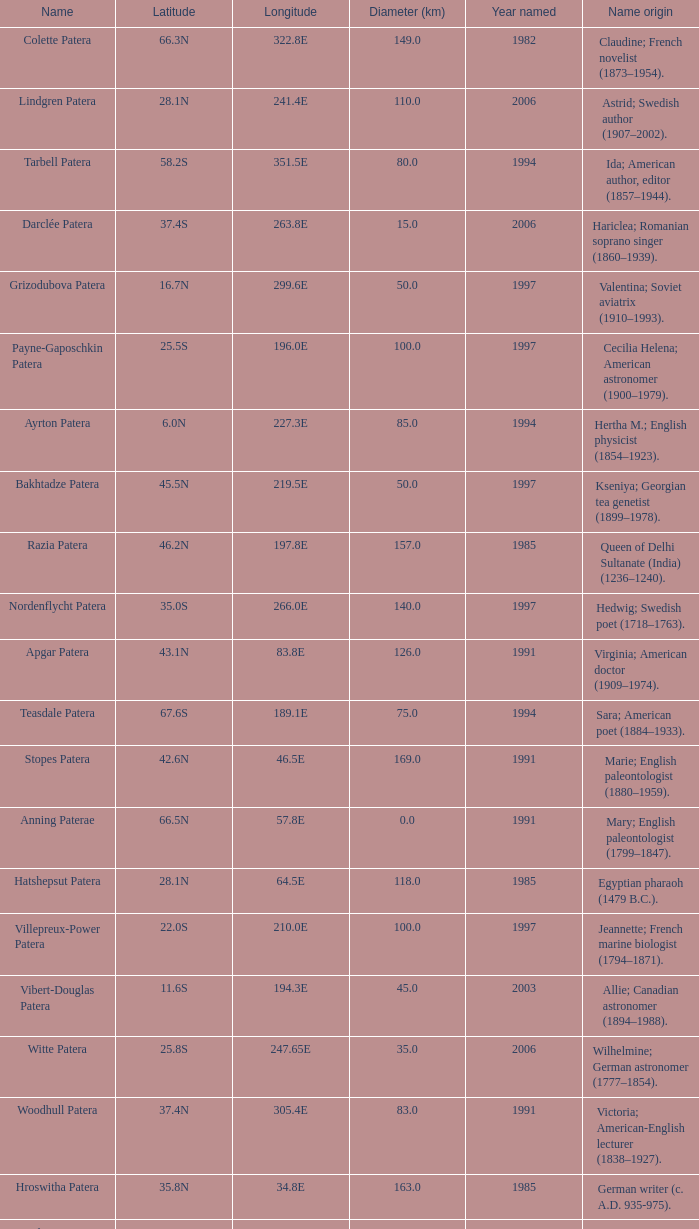What is the diameter in km of the feature named Colette Patera?  149.0. 